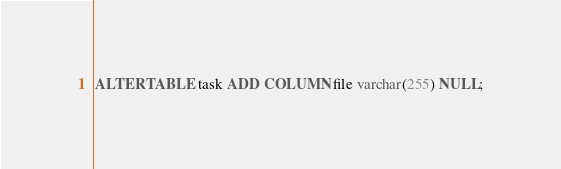Convert code to text. <code><loc_0><loc_0><loc_500><loc_500><_SQL_>ALTER TABLE task ADD COLUMN file varchar(255) NULL;</code> 